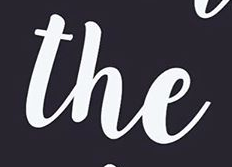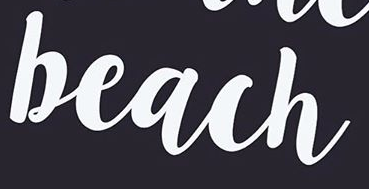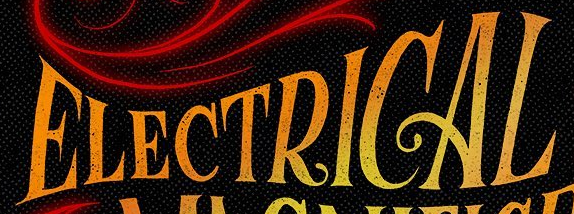Read the text from these images in sequence, separated by a semicolon. the; beach; ELECTRICAL 